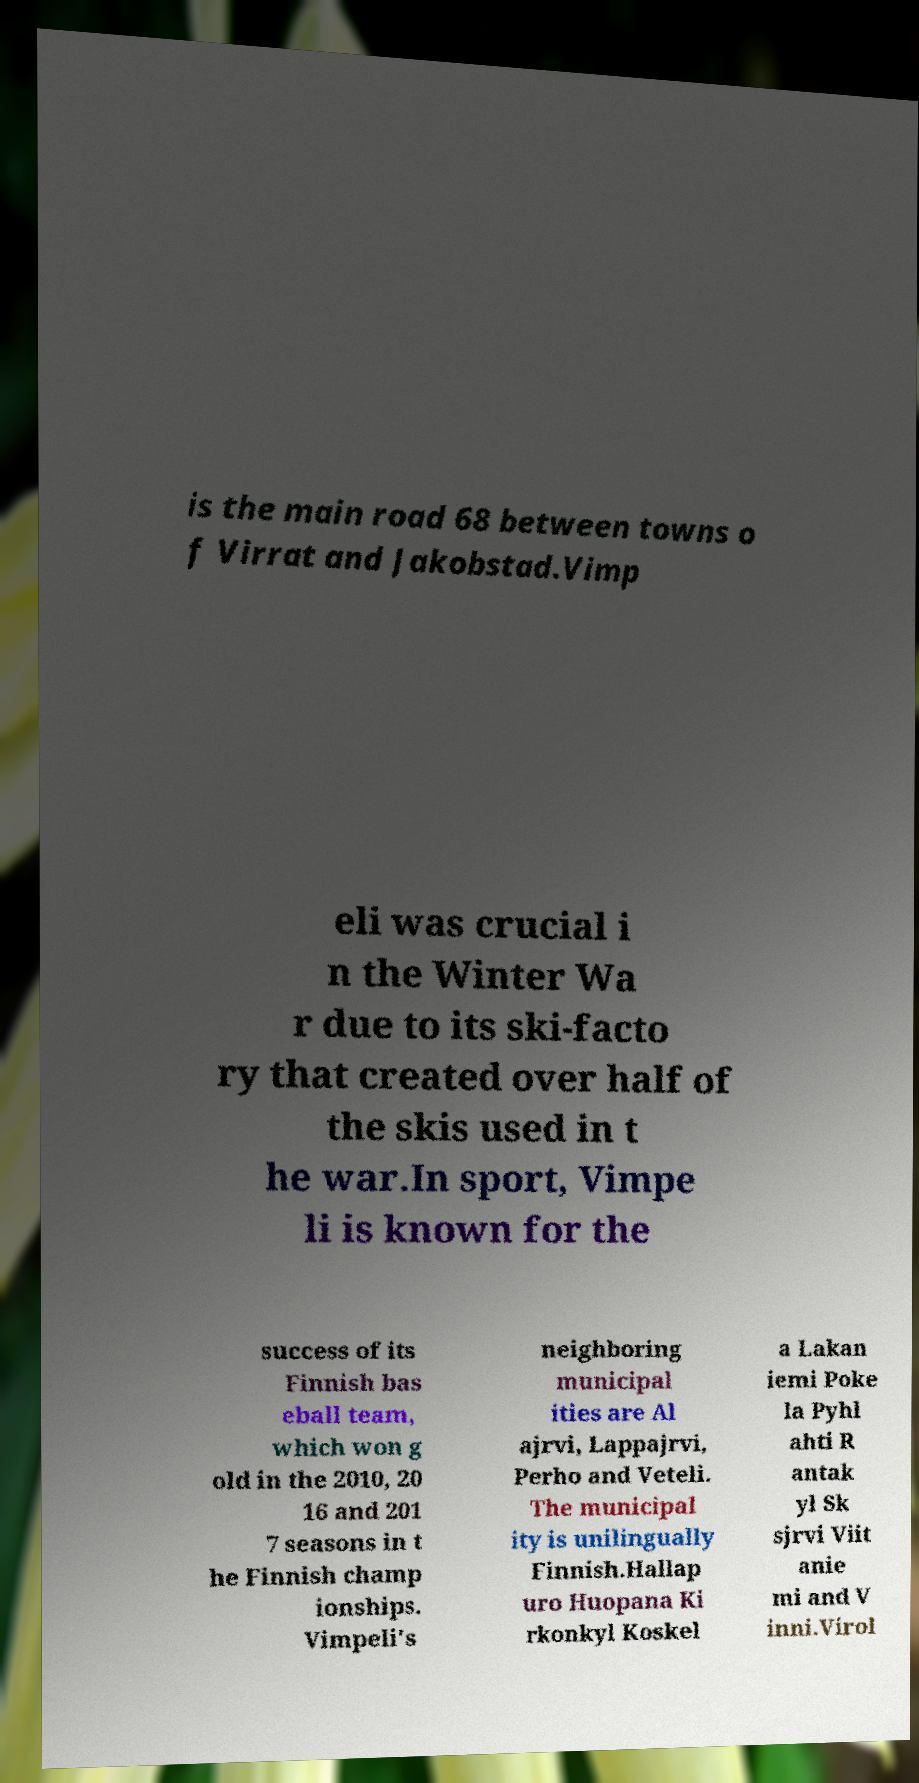Can you read and provide the text displayed in the image?This photo seems to have some interesting text. Can you extract and type it out for me? is the main road 68 between towns o f Virrat and Jakobstad.Vimp eli was crucial i n the Winter Wa r due to its ski-facto ry that created over half of the skis used in t he war.In sport, Vimpe li is known for the success of its Finnish bas eball team, which won g old in the 2010, 20 16 and 201 7 seasons in t he Finnish champ ionships. Vimpeli's neighboring municipal ities are Al ajrvi, Lappajrvi, Perho and Veteli. The municipal ity is unilingually Finnish.Hallap uro Huopana Ki rkonkyl Koskel a Lakan iemi Poke la Pyhl ahti R antak yl Sk sjrvi Viit anie mi and V inni.Virol 